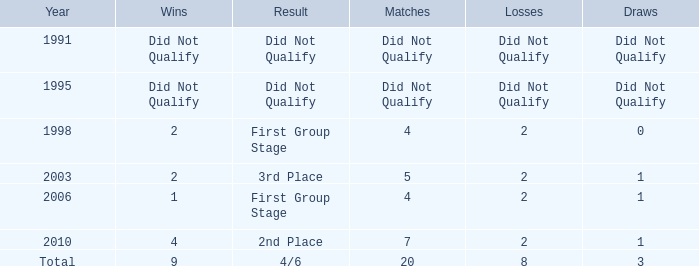What was the result for the team with 3 draws? 4/6. 